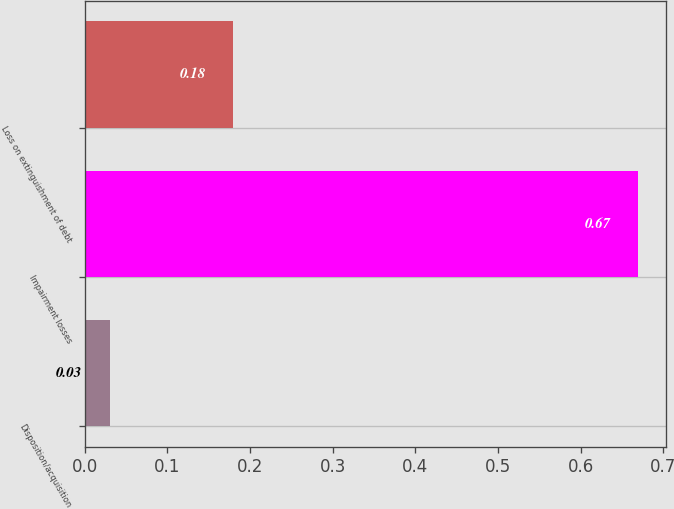<chart> <loc_0><loc_0><loc_500><loc_500><bar_chart><fcel>Disposition/acquisition<fcel>Impairment losses<fcel>Loss on extinguishment of debt<nl><fcel>0.03<fcel>0.67<fcel>0.18<nl></chart> 